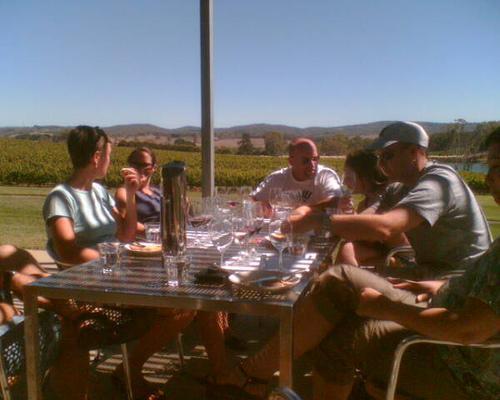How many people are in the photo?
Give a very brief answer. 5. 